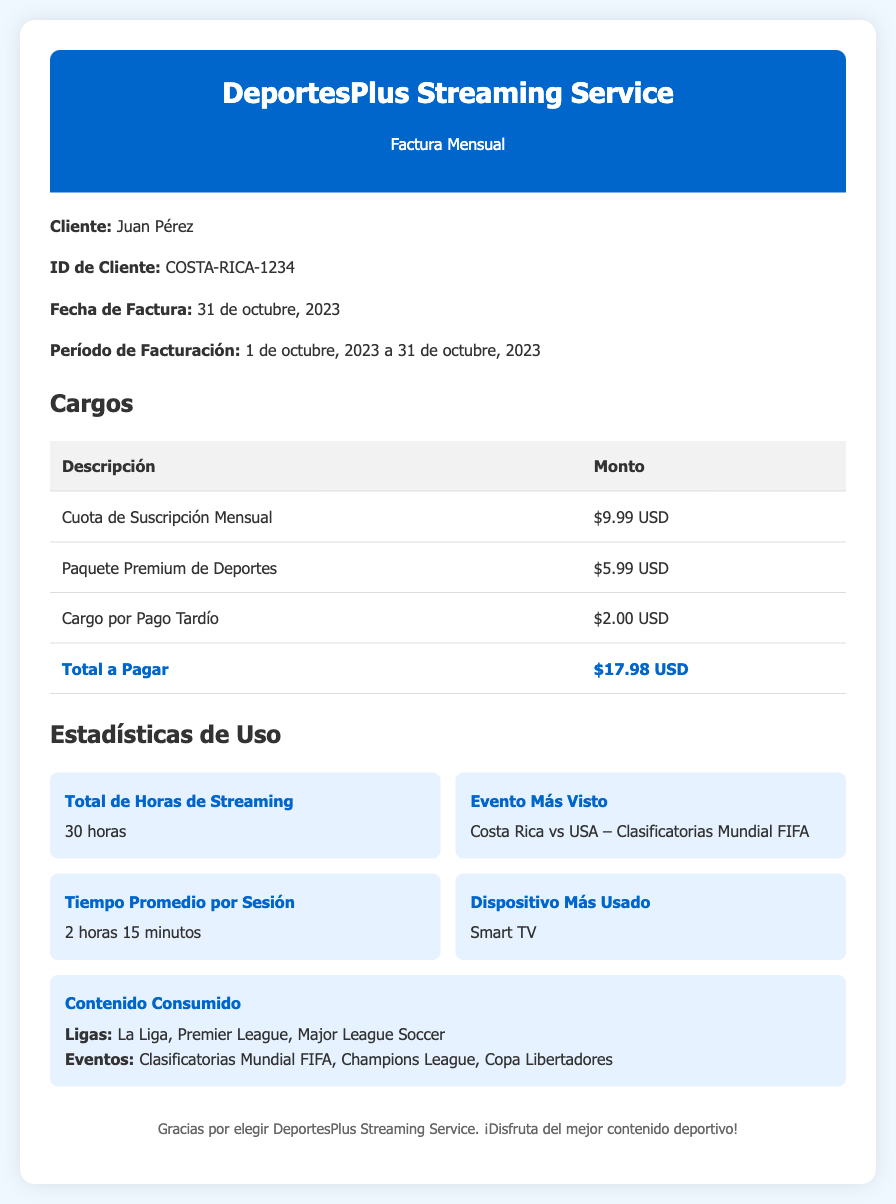What is the name of the customer? The document states the customer's name as Juan Pérez.
Answer: Juan Pérez What is the total amount due? The total amount to be paid is listed under the charges section as $17.98 USD.
Answer: $17.98 USD What was the most viewed event? The most viewed event mentioned is "Costa Rica vs USA – Clasificatorias Mundial FIFA."
Answer: Costa Rica vs USA – Clasificatorias Mundial FIFA How many hours of streaming were used? The total hours of streaming are provided in the usage statistics as 30 hours.
Answer: 30 horas What is the average time per session? The average time per session is stated as 2 hours 15 minutes.
Answer: 2 horas 15 minutos What was the payment late fee? The charge for late payment is specifically listed as $2.00 USD.
Answer: $2.00 USD What is the most used device? The document mentions the most used device as Smart TV.
Answer: Smart TV What is the billing period? The billing period outlined in the document is from 1 de octubre, 2023 to 31 de octubre, 2023.
Answer: 1 de octubre, 2023 a 31 de octubre, 2023 What sports leagues were consumed? The consumed leagues are listed as La Liga, Premier League, and Major League Soccer.
Answer: La Liga, Premier League, Major League Soccer 